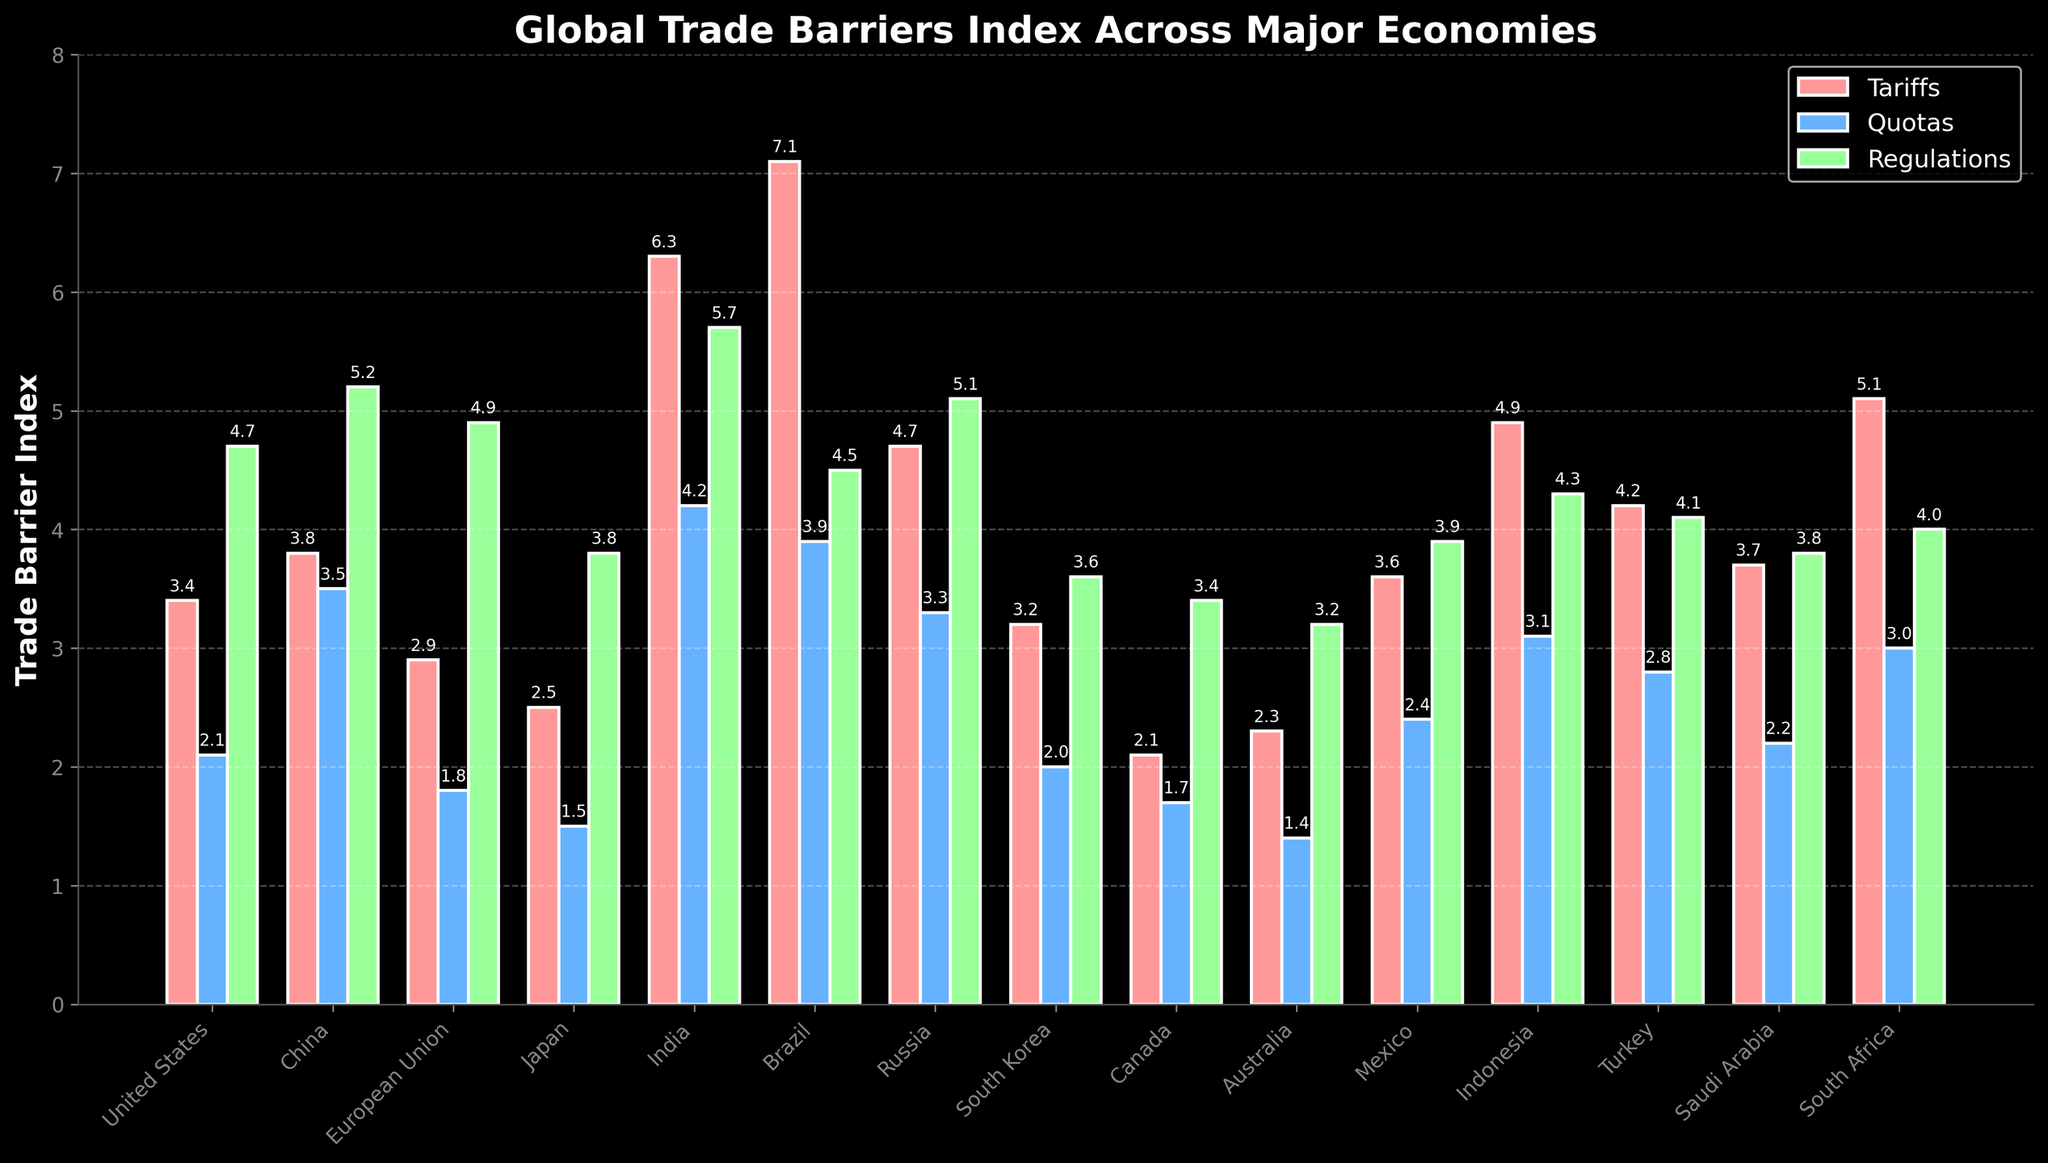Which country has the highest tariff index? By examining the bar heights in the Tariffs category (red bars), the highest bar belongs to Brazil, indicating that Brazil has the highest tariff index among the listed countries.
Answer: Brazil What is the difference between India's and Brazil's regulation indices? To find the difference, look at the green bars representing the regulation indices and subtract Brazil's index (4.5) from India's index (5.7). So, 5.7 - 4.5 = 1.2.
Answer: 1.2 Which category shows the largest trade barrier index for South Africa? By comparing the heights of the red, blue, and green bars for South Africa, the blue bar (Quotas) is the tallest, representing that South Africa has the largest trade barrier index in the Quotas category.
Answer: Quotas Is the tariff index of China greater than the quota index of Turkey? Compare the heights of the red bar for China (3.8) with the blue bar for Turkey (2.8). Since 3.8 is greater than 2.8, China's tariff index is indeed greater.
Answer: Yes What is the average regulation index across all countries? Sum the regulation indices for all countries and divide by the number of countries. The sum of regulation indices is 4.7 + 5.2 + 4.9 + 3.8 + 5.7 + 4.5 + 5.1 + 3.6 + 3.4 + 3.2 + 3.9 + 4.3 + 4.1 + 3.8 + 4.0 = 63.4. Divide by 15 countries: 63.4 / 15 ≈ 4.23.
Answer: 4.23 Which country has the lowest quota index and what is its value? Identify the shortest blue bar among all countries. The lowest blue bar corresponds to Japan, which has a quota index of 1.5.
Answer: Japan, 1.5 Compare the total trade barrier indices (sum of tariffs, quotas, regulations) for the United States and Indonesia. Which country has a higher total? Calculate the sum for each country: United States: 3.4 + 2.1 + 4.7 = 10.2; Indonesia: 4.9 + 3.1 + 4.3 = 12.3. Indonesia has a higher total trade barrier index.
Answer: Indonesia How much higher is Mexico’s quota index compared to Canada's? Subtract Canada's quota index (1.7) from Mexico's (2.4): 2.4 - 1.7 = 0.7.
Answer: 0.7 What is the combined tariff index for the European Union and Japan? Add the tariff indices for the European Union (2.9) and Japan (2.5): 2.9 + 2.5 = 5.4.
Answer: 5.4 Which countries have regulation indices lower than 4.0? Identify the countries with green bars less than 4.0. The countries are South Korea (3.6), Canada (3.4), and Australia (3.2).
Answer: South Korea, Canada, Australia 